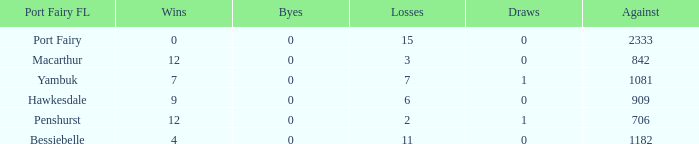How many wins for Port Fairy and against more than 2333? None. 